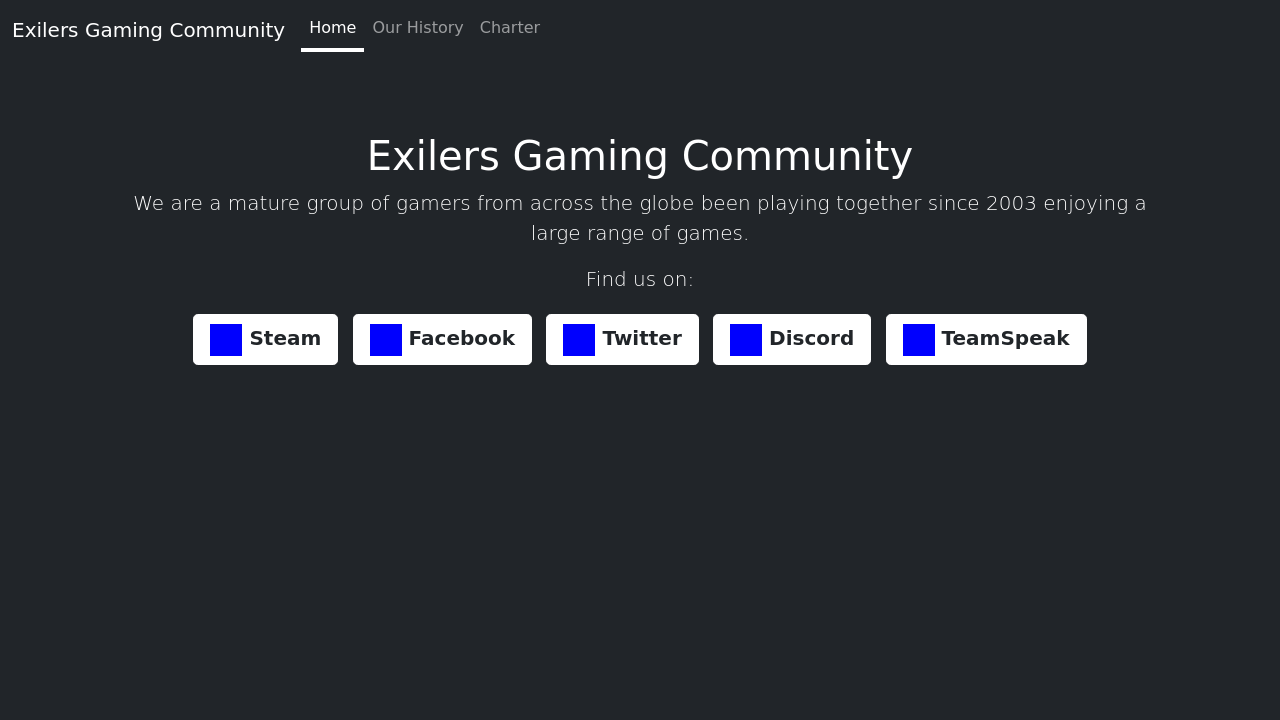Could you explain more about 'Our History' as mentioned on the Exilers Gaming Community's website page? Certainly! The 'Our History' section typically includes detailed information about the origins and evolution of the Exilers Gaming Community. It highlights the significant milestones since its formation in 2003, covering major gaming events, growth in community membership, and pivotal moments that shaped the group. If you're interested, I can help create a mock-up section that outlines a potential history timeline for the community. 